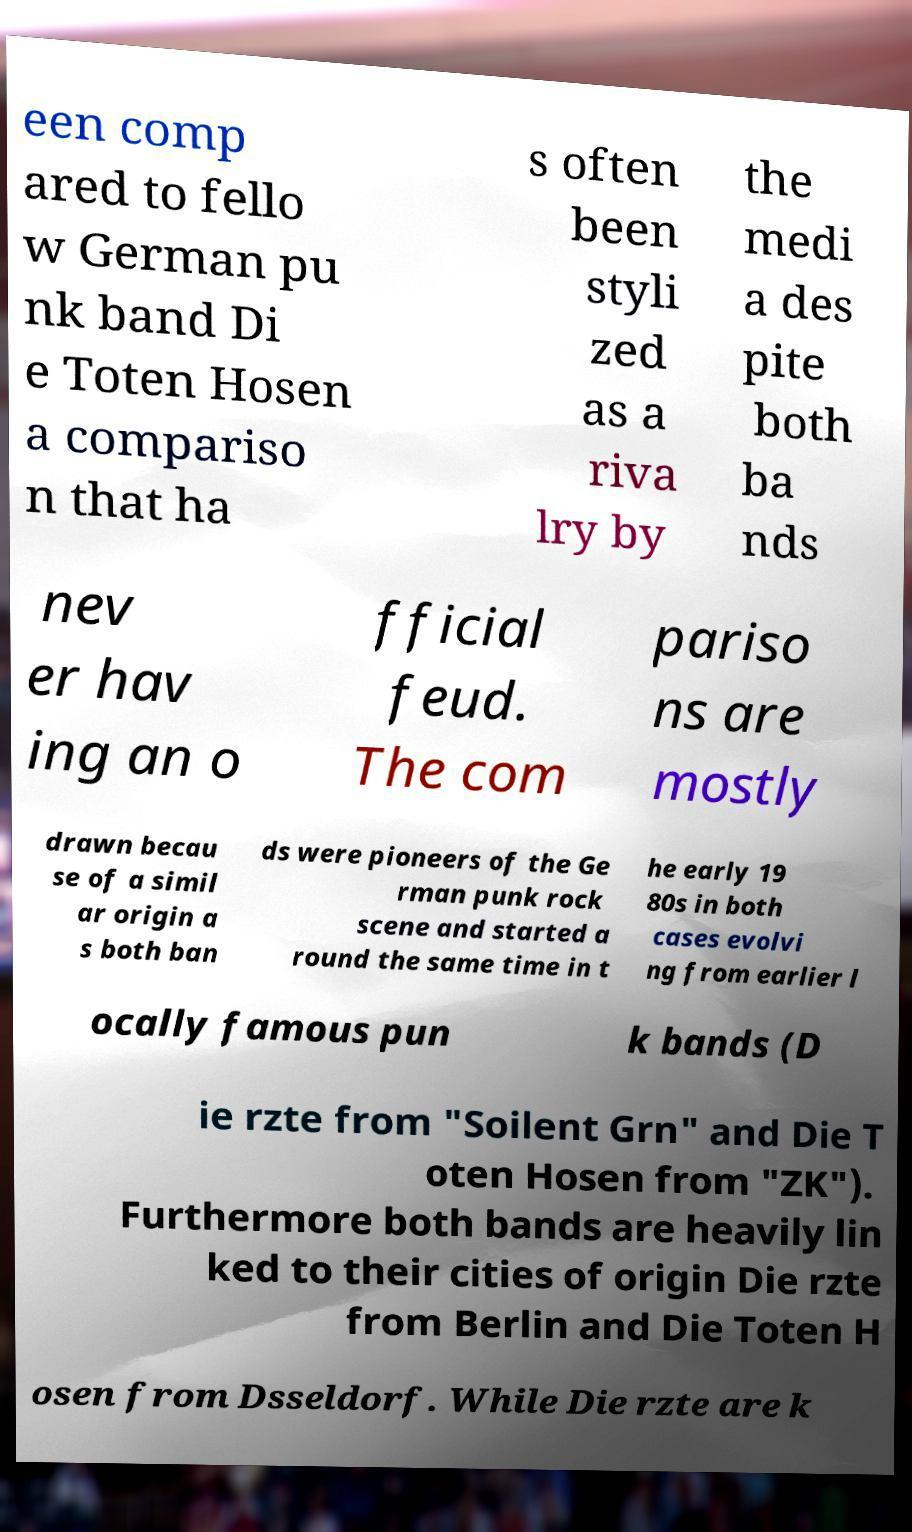Could you assist in decoding the text presented in this image and type it out clearly? een comp ared to fello w German pu nk band Di e Toten Hosen a compariso n that ha s often been styli zed as a riva lry by the medi a des pite both ba nds nev er hav ing an o fficial feud. The com pariso ns are mostly drawn becau se of a simil ar origin a s both ban ds were pioneers of the Ge rman punk rock scene and started a round the same time in t he early 19 80s in both cases evolvi ng from earlier l ocally famous pun k bands (D ie rzte from "Soilent Grn" and Die T oten Hosen from "ZK"). Furthermore both bands are heavily lin ked to their cities of origin Die rzte from Berlin and Die Toten H osen from Dsseldorf. While Die rzte are k 